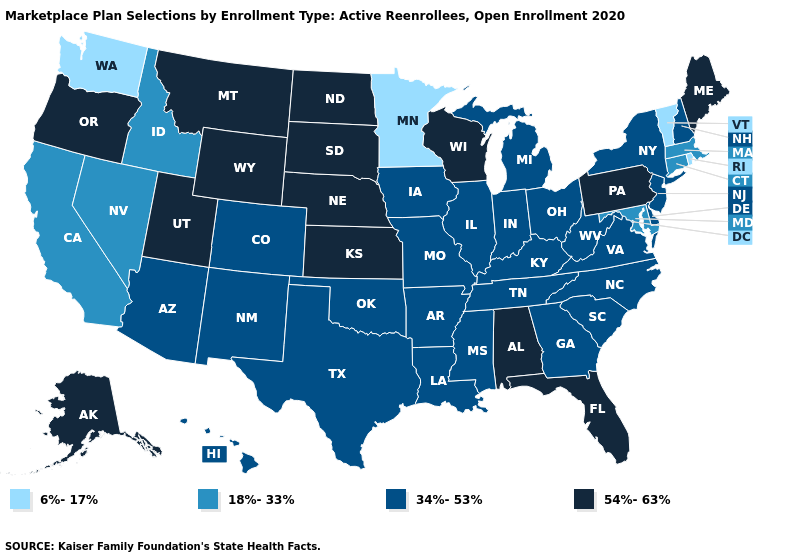Name the states that have a value in the range 34%-53%?
Short answer required. Arizona, Arkansas, Colorado, Delaware, Georgia, Hawaii, Illinois, Indiana, Iowa, Kentucky, Louisiana, Michigan, Mississippi, Missouri, New Hampshire, New Jersey, New Mexico, New York, North Carolina, Ohio, Oklahoma, South Carolina, Tennessee, Texas, Virginia, West Virginia. What is the value of New Mexico?
Write a very short answer. 34%-53%. What is the value of Connecticut?
Short answer required. 18%-33%. Which states hav the highest value in the South?
Keep it brief. Alabama, Florida. Among the states that border Montana , does North Dakota have the highest value?
Answer briefly. Yes. What is the highest value in the USA?
Concise answer only. 54%-63%. What is the lowest value in the West?
Quick response, please. 6%-17%. Name the states that have a value in the range 54%-63%?
Short answer required. Alabama, Alaska, Florida, Kansas, Maine, Montana, Nebraska, North Dakota, Oregon, Pennsylvania, South Dakota, Utah, Wisconsin, Wyoming. Does Virginia have the lowest value in the USA?
Concise answer only. No. What is the value of Tennessee?
Be succinct. 34%-53%. Which states have the highest value in the USA?
Short answer required. Alabama, Alaska, Florida, Kansas, Maine, Montana, Nebraska, North Dakota, Oregon, Pennsylvania, South Dakota, Utah, Wisconsin, Wyoming. Which states have the highest value in the USA?
Answer briefly. Alabama, Alaska, Florida, Kansas, Maine, Montana, Nebraska, North Dakota, Oregon, Pennsylvania, South Dakota, Utah, Wisconsin, Wyoming. Does Idaho have the lowest value in the USA?
Quick response, please. No. Name the states that have a value in the range 54%-63%?
Answer briefly. Alabama, Alaska, Florida, Kansas, Maine, Montana, Nebraska, North Dakota, Oregon, Pennsylvania, South Dakota, Utah, Wisconsin, Wyoming. Name the states that have a value in the range 54%-63%?
Be succinct. Alabama, Alaska, Florida, Kansas, Maine, Montana, Nebraska, North Dakota, Oregon, Pennsylvania, South Dakota, Utah, Wisconsin, Wyoming. 